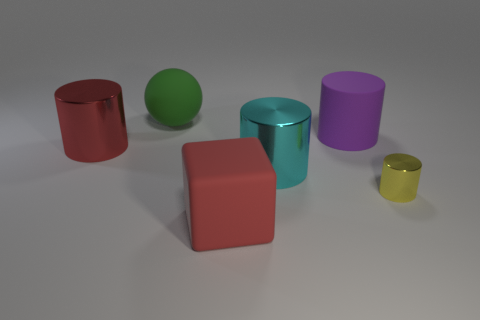Subtract all rubber cylinders. How many cylinders are left? 3 Add 3 big blue shiny cylinders. How many objects exist? 9 Subtract all purple cylinders. How many cylinders are left? 3 Add 2 big matte balls. How many big matte balls are left? 3 Add 5 gray shiny blocks. How many gray shiny blocks exist? 5 Subtract 1 cyan cylinders. How many objects are left? 5 Subtract all balls. How many objects are left? 5 Subtract all purple balls. Subtract all purple blocks. How many balls are left? 1 Subtract all small green shiny cubes. Subtract all matte cylinders. How many objects are left? 5 